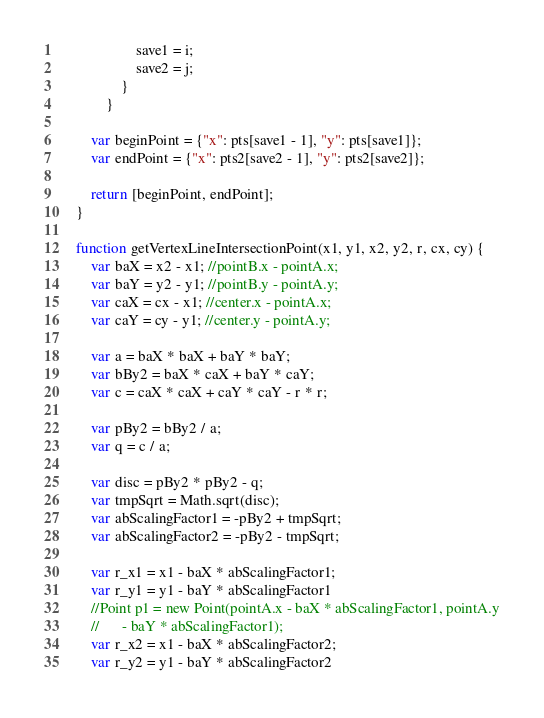<code> <loc_0><loc_0><loc_500><loc_500><_JavaScript_>                    save1 = i;
                    save2 = j;
                }
            }

        var beginPoint = {"x": pts[save1 - 1], "y": pts[save1]};
        var endPoint = {"x": pts2[save2 - 1], "y": pts2[save2]};

        return [beginPoint, endPoint];
    }

    function getVertexLineIntersectionPoint(x1, y1, x2, y2, r, cx, cy) {
        var baX = x2 - x1; //pointB.x - pointA.x;
        var baY = y2 - y1; //pointB.y - pointA.y;
        var caX = cx - x1; //center.x - pointA.x;
        var caY = cy - y1; //center.y - pointA.y;

        var a = baX * baX + baY * baY;
        var bBy2 = baX * caX + baY * caY;
        var c = caX * caX + caY * caY - r * r;

        var pBy2 = bBy2 / a;
        var q = c / a;

        var disc = pBy2 * pBy2 - q;
        var tmpSqrt = Math.sqrt(disc);
        var abScalingFactor1 = -pBy2 + tmpSqrt;
        var abScalingFactor2 = -pBy2 - tmpSqrt;

        var r_x1 = x1 - baX * abScalingFactor1;
        var r_y1 = y1 - baY * abScalingFactor1
        //Point p1 = new Point(pointA.x - baX * abScalingFactor1, pointA.y
        //      - baY * abScalingFactor1);
        var r_x2 = x1 - baX * abScalingFactor2;
        var r_y2 = y1 - baY * abScalingFactor2
</code> 